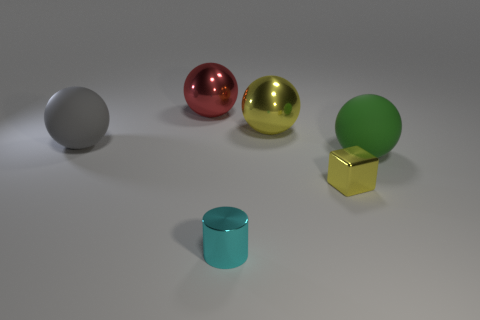There is a tiny cyan metallic object; what shape is it?
Offer a terse response. Cylinder. The small block that is the same material as the small cylinder is what color?
Make the answer very short. Yellow. How many brown objects are either small rubber spheres or large shiny objects?
Give a very brief answer. 0. Are there more big red spheres than large brown metallic cylinders?
Ensure brevity in your answer.  Yes. How many objects are red metal objects that are behind the large green rubber object or spheres that are to the right of the big gray matte sphere?
Make the answer very short. 3. There is a thing that is the same size as the yellow metallic cube; what is its color?
Offer a terse response. Cyan. Are the red sphere and the cyan thing made of the same material?
Keep it short and to the point. Yes. The big thing that is in front of the big matte sphere left of the red thing is made of what material?
Your answer should be compact. Rubber. Are there more yellow metal objects in front of the big yellow sphere than big cyan blocks?
Offer a very short reply. Yes. What number of other things are there of the same size as the gray rubber thing?
Make the answer very short. 3. 